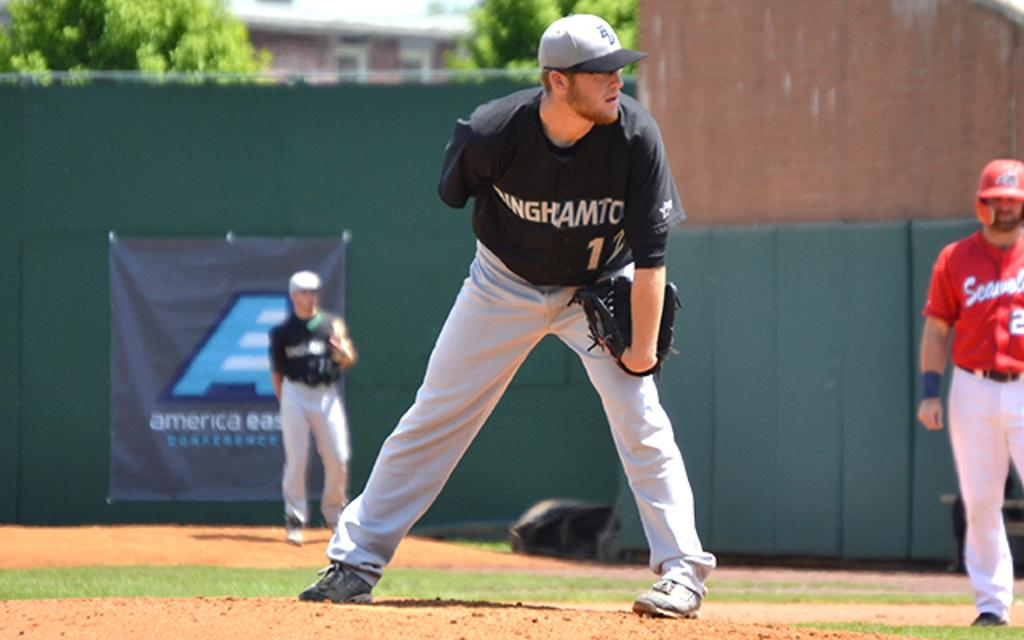<image>
Create a compact narrative representing the image presented. A baseball pitcher in a Binghamton uniform readies himself to throw. 